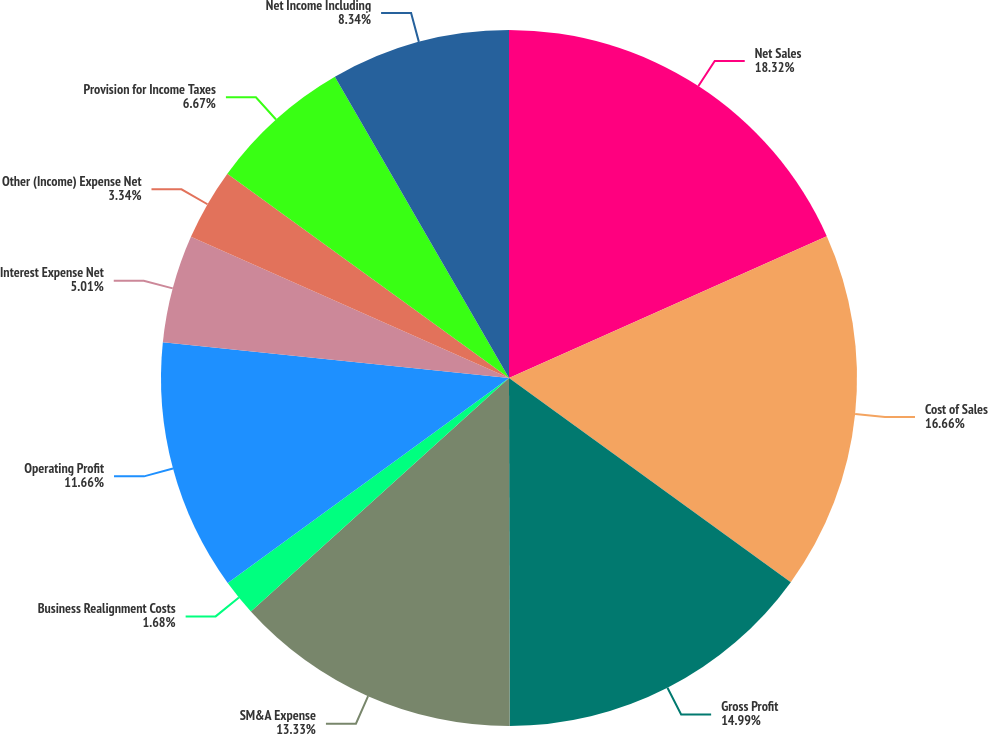<chart> <loc_0><loc_0><loc_500><loc_500><pie_chart><fcel>Net Sales<fcel>Cost of Sales<fcel>Gross Profit<fcel>SM&A Expense<fcel>Business Realignment Costs<fcel>Operating Profit<fcel>Interest Expense Net<fcel>Other (Income) Expense Net<fcel>Provision for Income Taxes<fcel>Net Income Including<nl><fcel>18.32%<fcel>16.66%<fcel>14.99%<fcel>13.33%<fcel>1.68%<fcel>11.66%<fcel>5.01%<fcel>3.34%<fcel>6.67%<fcel>8.34%<nl></chart> 